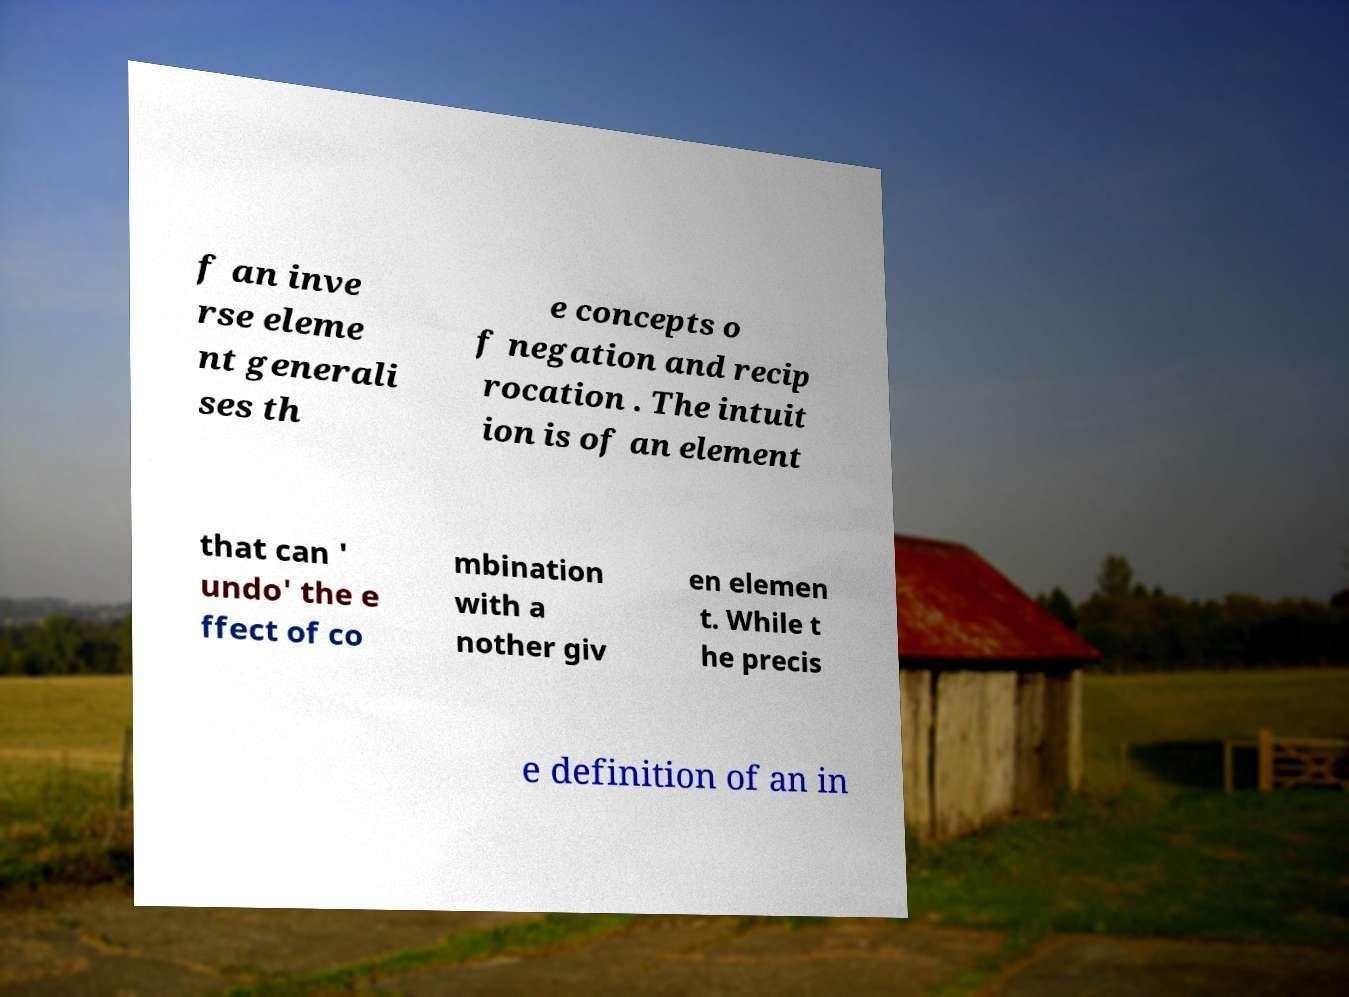What messages or text are displayed in this image? I need them in a readable, typed format. f an inve rse eleme nt generali ses th e concepts o f negation and recip rocation . The intuit ion is of an element that can ' undo' the e ffect of co mbination with a nother giv en elemen t. While t he precis e definition of an in 